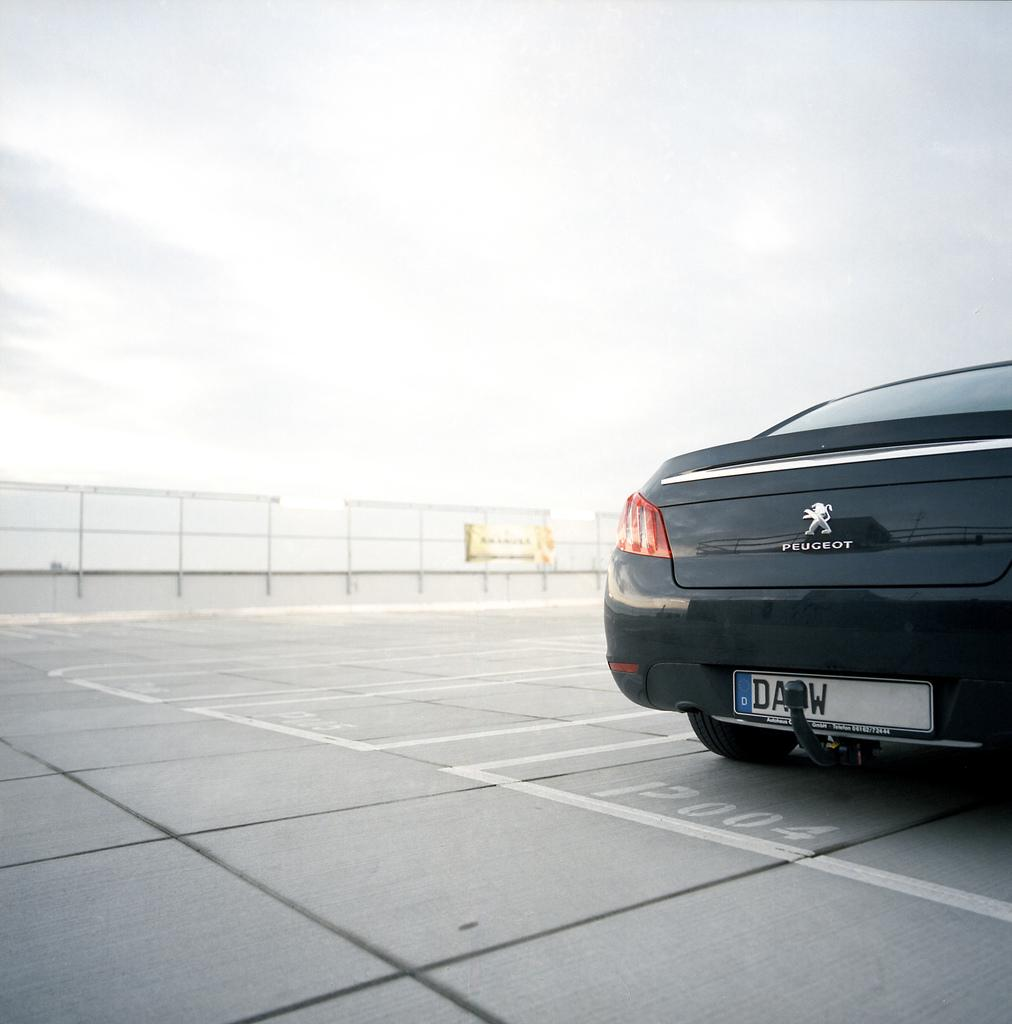What is located on the right side of the image? There is a vehicle on the right side of the image. Where is the vehicle situated? The vehicle is on the road. What can be seen on the road in the image? There are white color lines on the road. What is visible in the background of the image? There is a fence in the background of the image. What is visible in the sky in the image? There are clouds in the sky. How many cats are sitting on the vehicle in the image? There are no cats present in the image; it only features a vehicle on the road. What type of form does the vehicle have in the image? The image does not provide enough information to describe the vehicle's form or shape. 